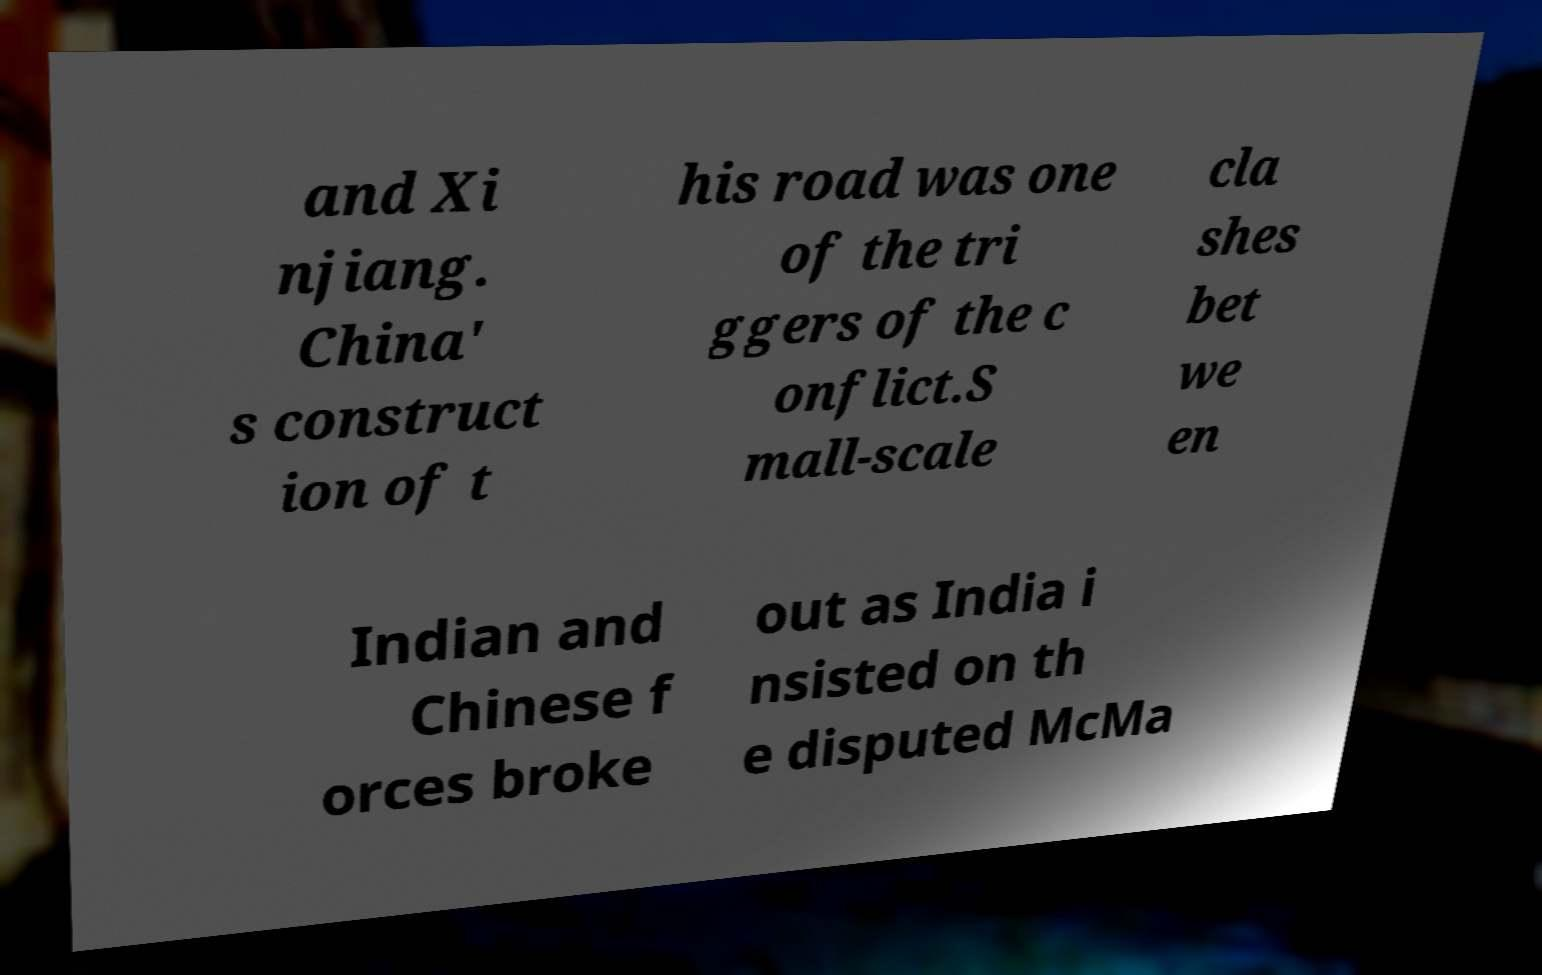Please read and relay the text visible in this image. What does it say? and Xi njiang. China' s construct ion of t his road was one of the tri ggers of the c onflict.S mall-scale cla shes bet we en Indian and Chinese f orces broke out as India i nsisted on th e disputed McMa 